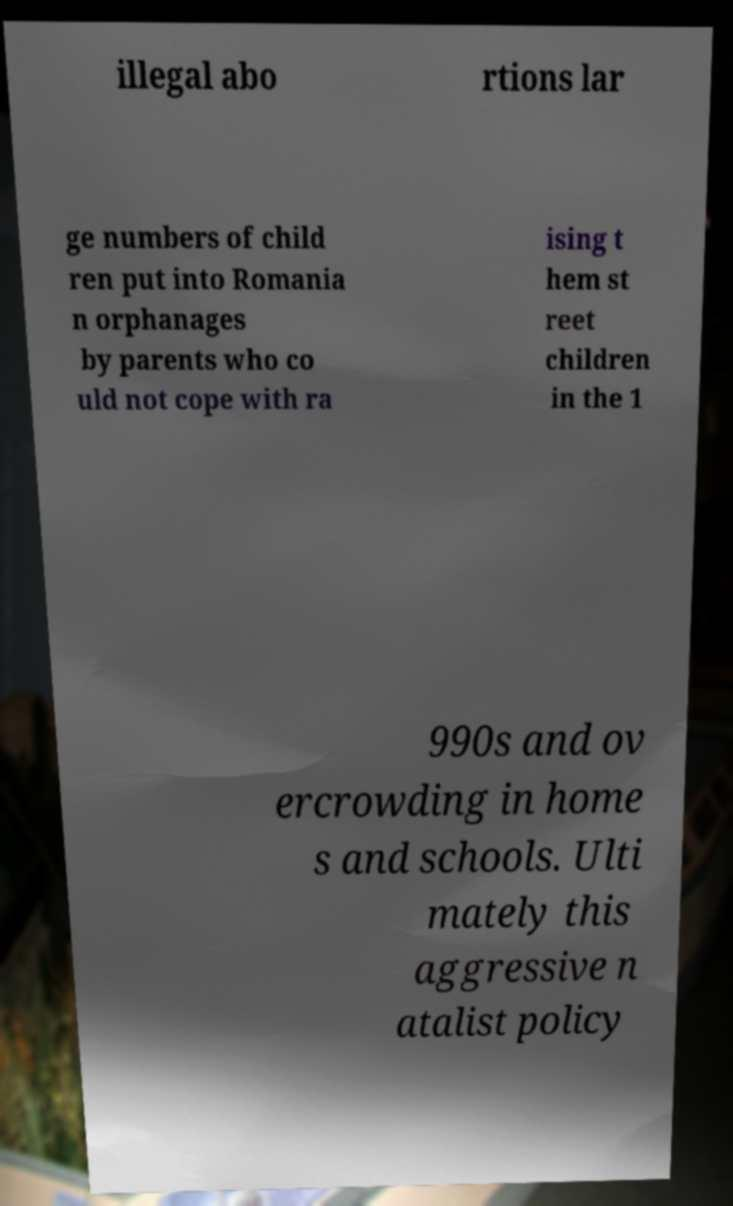Can you read and provide the text displayed in the image?This photo seems to have some interesting text. Can you extract and type it out for me? illegal abo rtions lar ge numbers of child ren put into Romania n orphanages by parents who co uld not cope with ra ising t hem st reet children in the 1 990s and ov ercrowding in home s and schools. Ulti mately this aggressive n atalist policy 